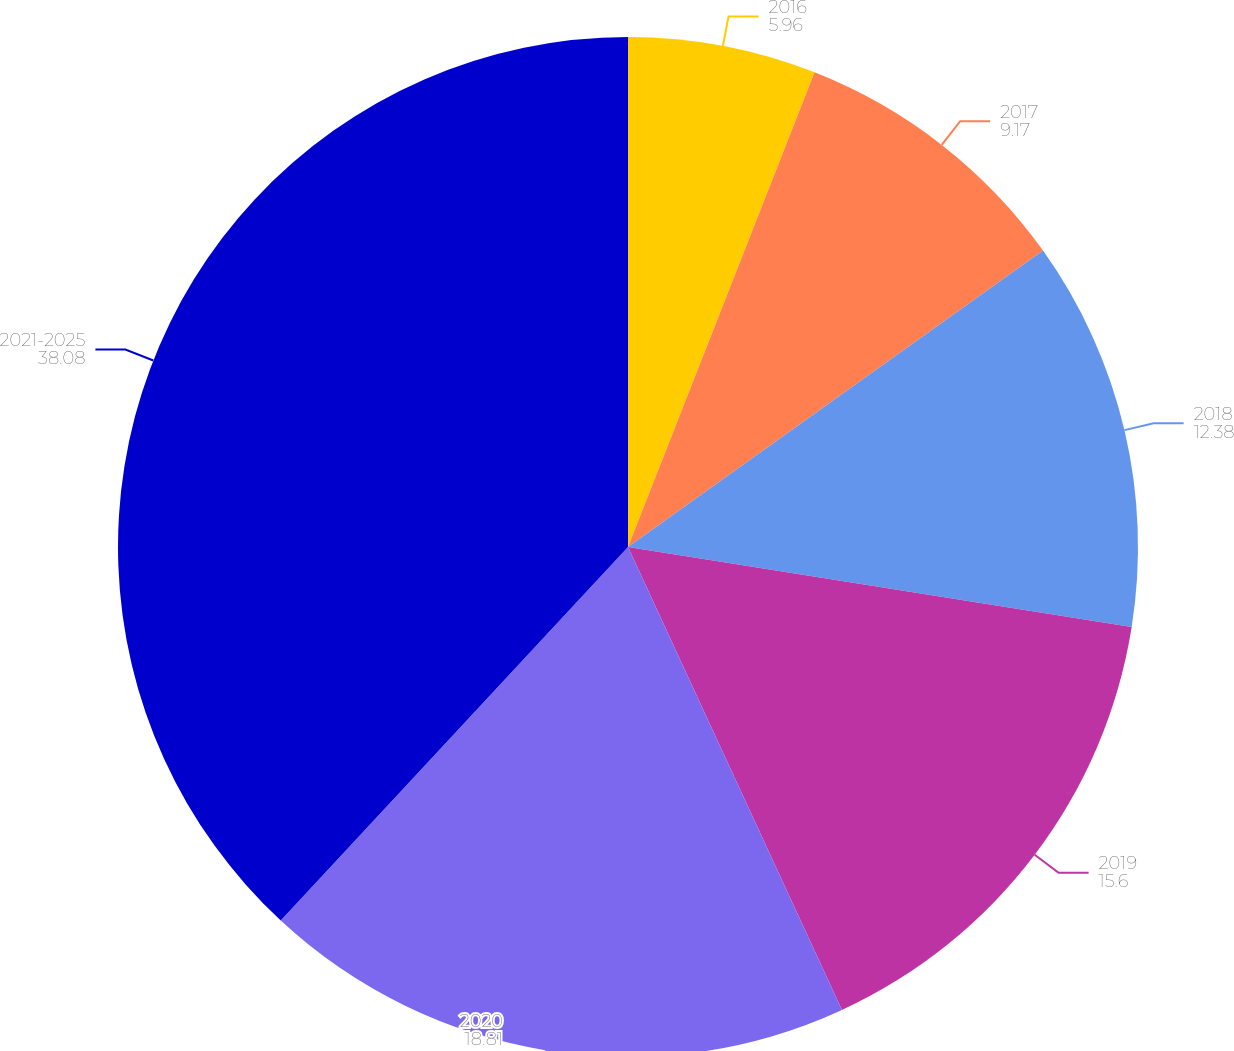Convert chart. <chart><loc_0><loc_0><loc_500><loc_500><pie_chart><fcel>2016<fcel>2017<fcel>2018<fcel>2019<fcel>2020<fcel>2021-2025<nl><fcel>5.96%<fcel>9.17%<fcel>12.38%<fcel>15.6%<fcel>18.81%<fcel>38.08%<nl></chart> 